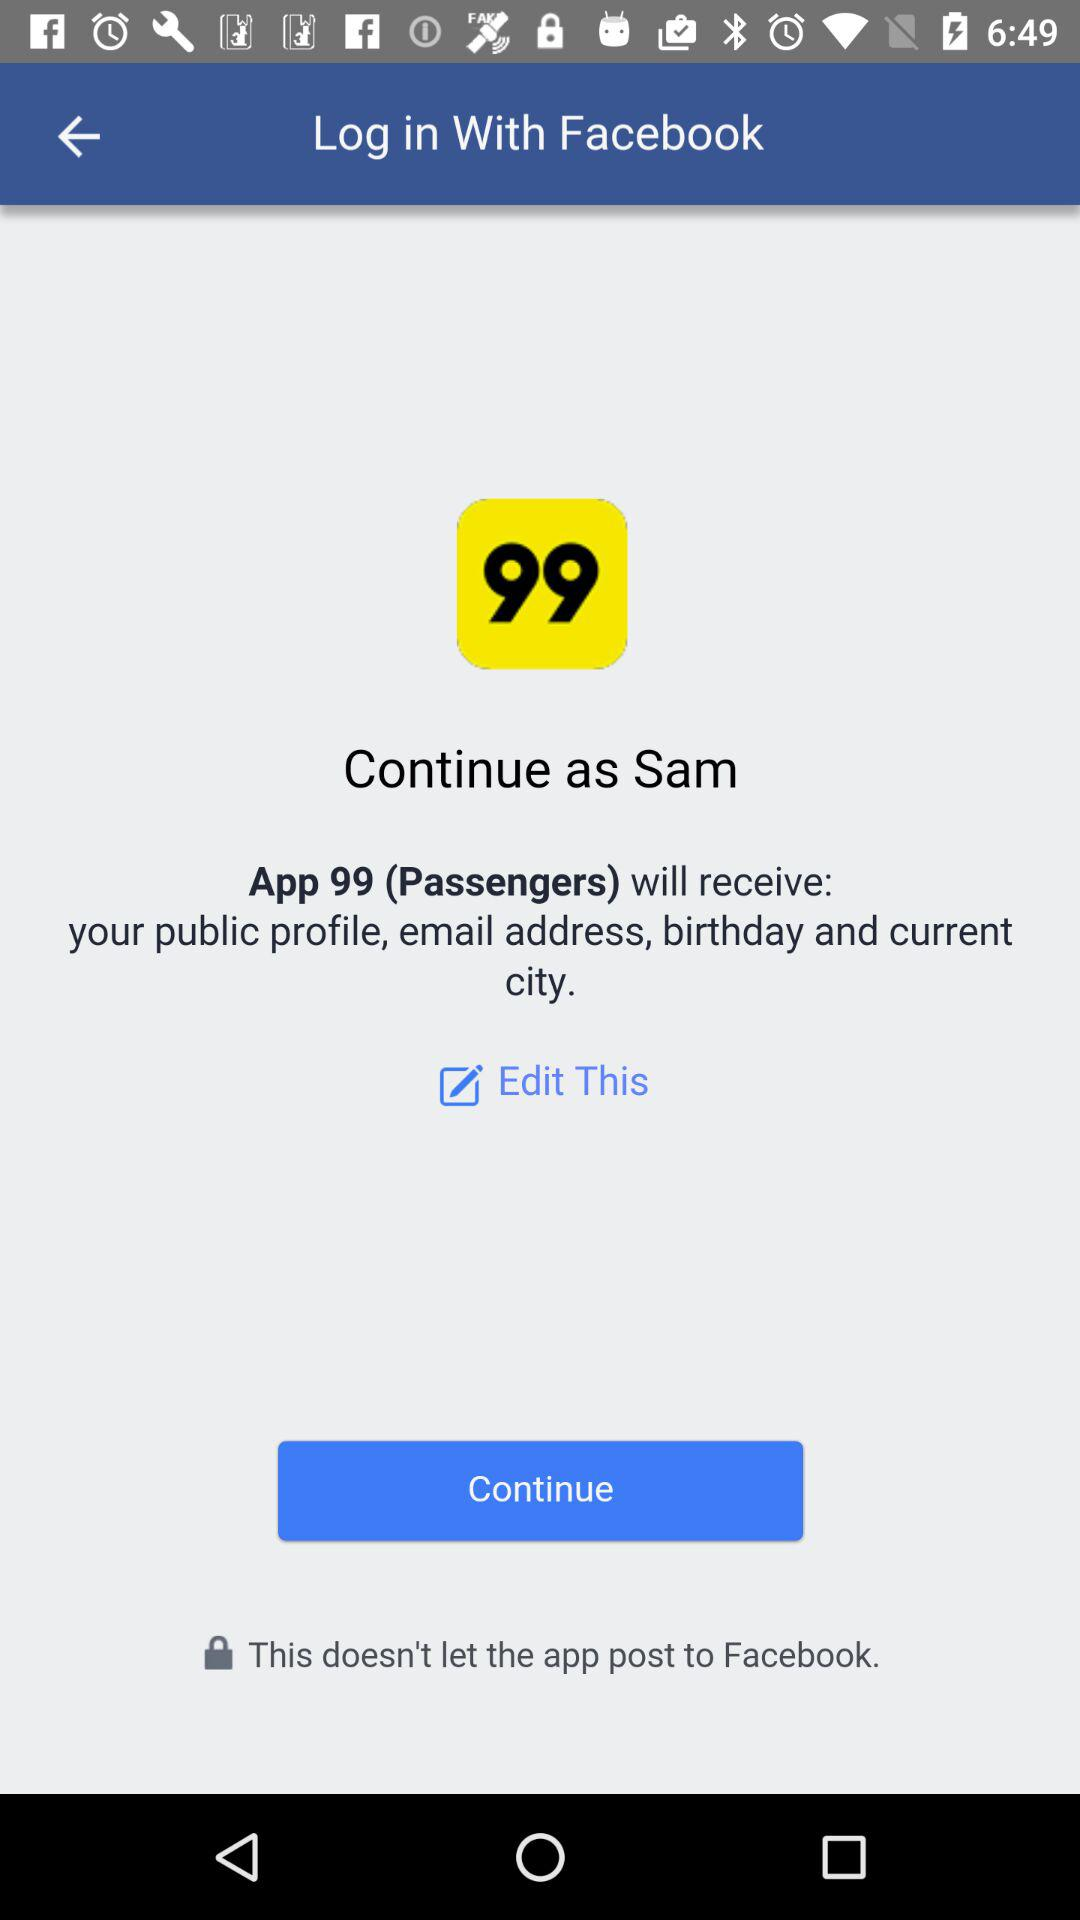What application will receive the details? The application is "App 99 (Passengers)". 